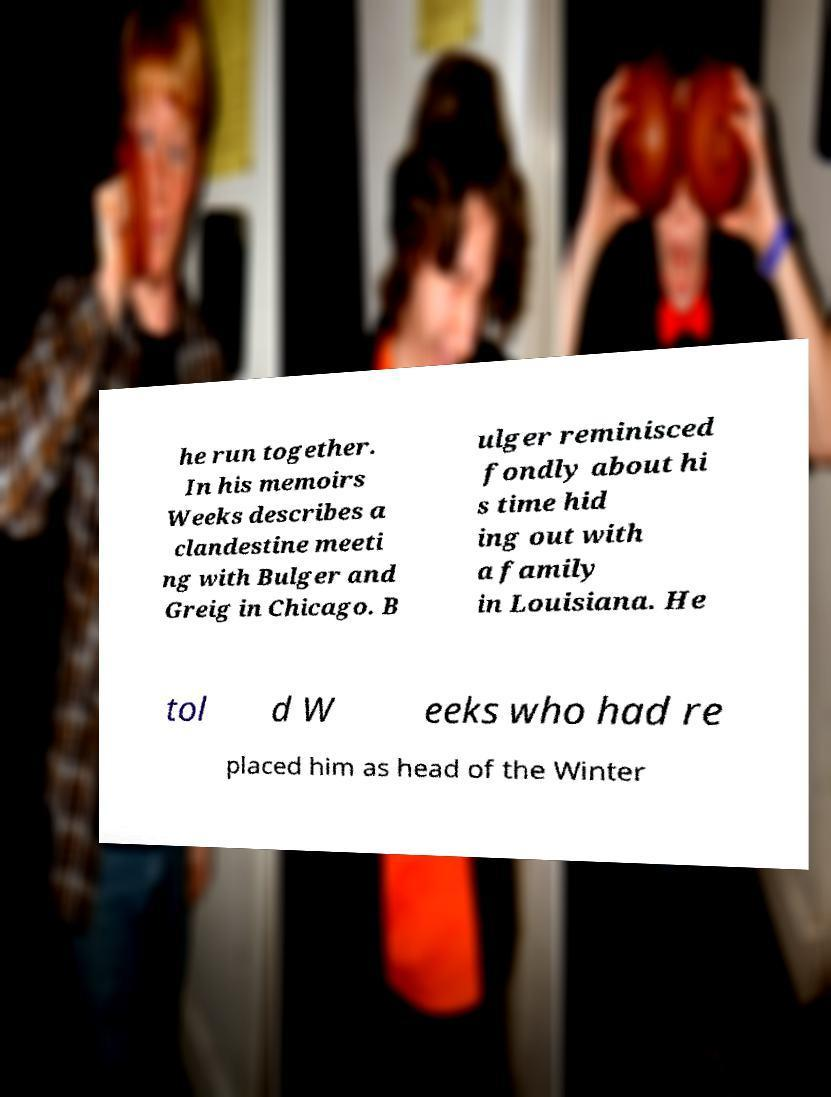Please read and relay the text visible in this image. What does it say? he run together. In his memoirs Weeks describes a clandestine meeti ng with Bulger and Greig in Chicago. B ulger reminisced fondly about hi s time hid ing out with a family in Louisiana. He tol d W eeks who had re placed him as head of the Winter 